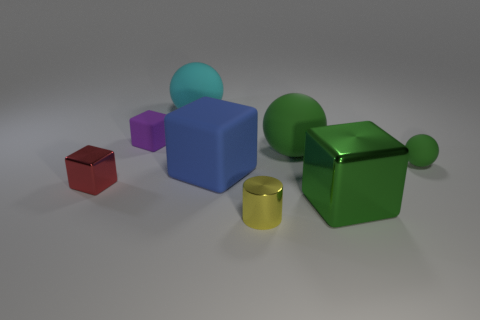Are there any red metallic blocks left of the big blue cube?
Give a very brief answer. Yes. Is the number of large things that are in front of the large green rubber object the same as the number of tiny purple things?
Keep it short and to the point. No. Is there a cyan object left of the tiny object that is behind the small rubber object right of the cyan rubber sphere?
Offer a terse response. No. What is the small red object made of?
Your answer should be very brief. Metal. What number of other things are there of the same shape as the small red metallic object?
Your response must be concise. 3. Is the small purple thing the same shape as the tiny green rubber object?
Ensure brevity in your answer.  No. How many objects are balls left of the tiny matte ball or metallic objects that are on the right side of the tiny purple rubber block?
Your response must be concise. 4. How many objects are either tiny purple matte cubes or big yellow metallic balls?
Ensure brevity in your answer.  1. What number of purple matte cubes are on the left side of the green matte sphere on the right side of the green block?
Give a very brief answer. 1. What number of other things are there of the same size as the cyan matte object?
Make the answer very short. 3. 